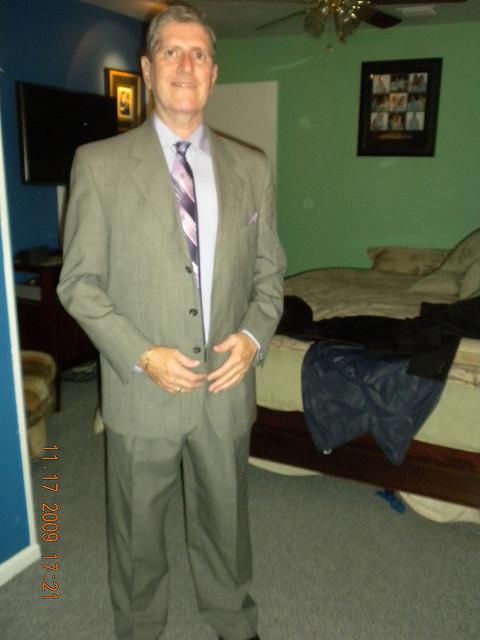Is this person wearing a business suit?
Short answer required. Yes. Is the person in a home?
Give a very brief answer. Yes. IS the bed made?
Concise answer only. No. 